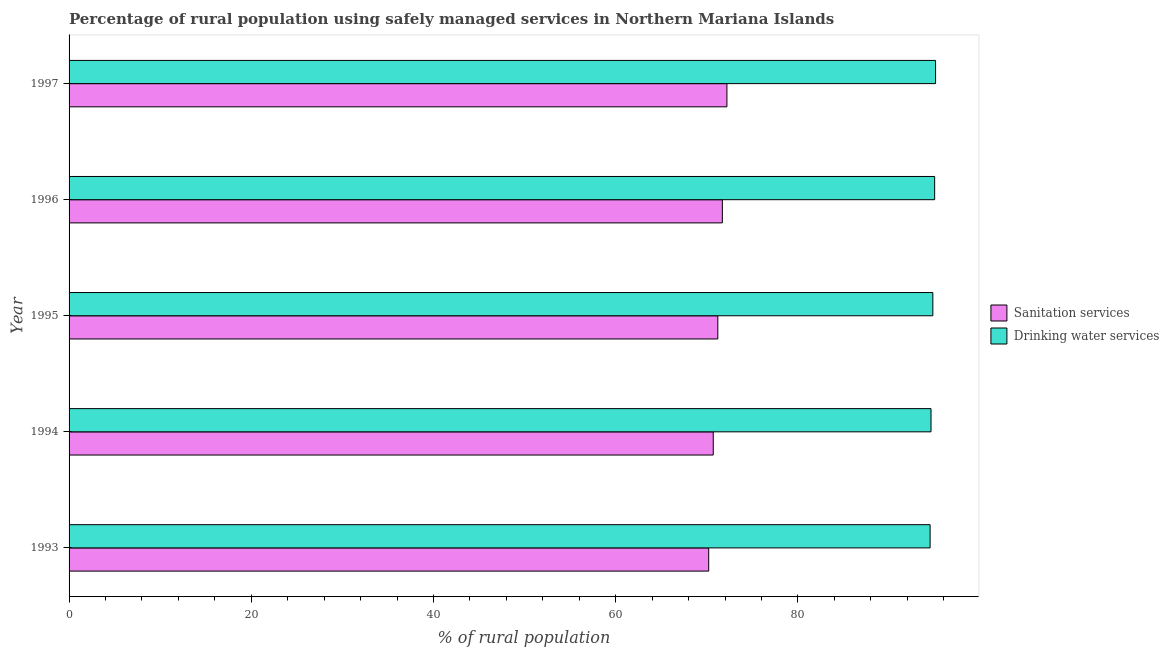How many groups of bars are there?
Ensure brevity in your answer.  5. Are the number of bars on each tick of the Y-axis equal?
Offer a very short reply. Yes. In how many cases, is the number of bars for a given year not equal to the number of legend labels?
Your answer should be compact. 0. What is the percentage of rural population who used drinking water services in 1997?
Your response must be concise. 95.1. Across all years, what is the maximum percentage of rural population who used drinking water services?
Provide a short and direct response. 95.1. Across all years, what is the minimum percentage of rural population who used drinking water services?
Your answer should be compact. 94.5. In which year was the percentage of rural population who used sanitation services maximum?
Provide a succinct answer. 1997. What is the total percentage of rural population who used drinking water services in the graph?
Keep it short and to the point. 474. What is the difference between the percentage of rural population who used drinking water services in 1994 and the percentage of rural population who used sanitation services in 1995?
Provide a succinct answer. 23.4. What is the average percentage of rural population who used drinking water services per year?
Your response must be concise. 94.8. In the year 1995, what is the difference between the percentage of rural population who used sanitation services and percentage of rural population who used drinking water services?
Give a very brief answer. -23.6. In how many years, is the percentage of rural population who used drinking water services greater than 48 %?
Your response must be concise. 5. Is the percentage of rural population who used sanitation services in 1994 less than that in 1996?
Make the answer very short. Yes. What is the difference between the highest and the second highest percentage of rural population who used sanitation services?
Offer a terse response. 0.5. Is the sum of the percentage of rural population who used drinking water services in 1994 and 1997 greater than the maximum percentage of rural population who used sanitation services across all years?
Give a very brief answer. Yes. What does the 2nd bar from the top in 1995 represents?
Make the answer very short. Sanitation services. What does the 1st bar from the bottom in 1995 represents?
Make the answer very short. Sanitation services. How many bars are there?
Offer a terse response. 10. Are all the bars in the graph horizontal?
Make the answer very short. Yes. How many years are there in the graph?
Keep it short and to the point. 5. What is the difference between two consecutive major ticks on the X-axis?
Provide a short and direct response. 20. Are the values on the major ticks of X-axis written in scientific E-notation?
Your answer should be compact. No. Does the graph contain any zero values?
Your answer should be compact. No. Does the graph contain grids?
Offer a very short reply. No. Where does the legend appear in the graph?
Your answer should be very brief. Center right. What is the title of the graph?
Your answer should be very brief. Percentage of rural population using safely managed services in Northern Mariana Islands. Does "Age 65(male)" appear as one of the legend labels in the graph?
Make the answer very short. No. What is the label or title of the X-axis?
Make the answer very short. % of rural population. What is the % of rural population of Sanitation services in 1993?
Keep it short and to the point. 70.2. What is the % of rural population in Drinking water services in 1993?
Ensure brevity in your answer.  94.5. What is the % of rural population in Sanitation services in 1994?
Your answer should be very brief. 70.7. What is the % of rural population in Drinking water services in 1994?
Make the answer very short. 94.6. What is the % of rural population in Sanitation services in 1995?
Keep it short and to the point. 71.2. What is the % of rural population of Drinking water services in 1995?
Provide a succinct answer. 94.8. What is the % of rural population in Sanitation services in 1996?
Your answer should be compact. 71.7. What is the % of rural population in Drinking water services in 1996?
Your answer should be compact. 95. What is the % of rural population in Sanitation services in 1997?
Offer a terse response. 72.2. What is the % of rural population in Drinking water services in 1997?
Give a very brief answer. 95.1. Across all years, what is the maximum % of rural population in Sanitation services?
Make the answer very short. 72.2. Across all years, what is the maximum % of rural population of Drinking water services?
Your answer should be very brief. 95.1. Across all years, what is the minimum % of rural population of Sanitation services?
Your answer should be compact. 70.2. Across all years, what is the minimum % of rural population in Drinking water services?
Keep it short and to the point. 94.5. What is the total % of rural population in Sanitation services in the graph?
Offer a very short reply. 356. What is the total % of rural population of Drinking water services in the graph?
Your answer should be very brief. 474. What is the difference between the % of rural population in Sanitation services in 1993 and that in 1994?
Ensure brevity in your answer.  -0.5. What is the difference between the % of rural population in Drinking water services in 1993 and that in 1994?
Offer a very short reply. -0.1. What is the difference between the % of rural population in Sanitation services in 1993 and that in 1996?
Provide a short and direct response. -1.5. What is the difference between the % of rural population in Drinking water services in 1993 and that in 1996?
Keep it short and to the point. -0.5. What is the difference between the % of rural population of Sanitation services in 1994 and that in 1997?
Offer a very short reply. -1.5. What is the difference between the % of rural population of Sanitation services in 1995 and that in 1996?
Your answer should be very brief. -0.5. What is the difference between the % of rural population in Drinking water services in 1995 and that in 1996?
Your answer should be compact. -0.2. What is the difference between the % of rural population in Sanitation services in 1995 and that in 1997?
Offer a very short reply. -1. What is the difference between the % of rural population of Drinking water services in 1995 and that in 1997?
Offer a very short reply. -0.3. What is the difference between the % of rural population in Sanitation services in 1996 and that in 1997?
Your answer should be very brief. -0.5. What is the difference between the % of rural population of Drinking water services in 1996 and that in 1997?
Make the answer very short. -0.1. What is the difference between the % of rural population of Sanitation services in 1993 and the % of rural population of Drinking water services in 1994?
Your answer should be very brief. -24.4. What is the difference between the % of rural population of Sanitation services in 1993 and the % of rural population of Drinking water services in 1995?
Offer a terse response. -24.6. What is the difference between the % of rural population in Sanitation services in 1993 and the % of rural population in Drinking water services in 1996?
Give a very brief answer. -24.8. What is the difference between the % of rural population in Sanitation services in 1993 and the % of rural population in Drinking water services in 1997?
Offer a terse response. -24.9. What is the difference between the % of rural population of Sanitation services in 1994 and the % of rural population of Drinking water services in 1995?
Keep it short and to the point. -24.1. What is the difference between the % of rural population in Sanitation services in 1994 and the % of rural population in Drinking water services in 1996?
Keep it short and to the point. -24.3. What is the difference between the % of rural population in Sanitation services in 1994 and the % of rural population in Drinking water services in 1997?
Offer a terse response. -24.4. What is the difference between the % of rural population in Sanitation services in 1995 and the % of rural population in Drinking water services in 1996?
Your response must be concise. -23.8. What is the difference between the % of rural population in Sanitation services in 1995 and the % of rural population in Drinking water services in 1997?
Give a very brief answer. -23.9. What is the difference between the % of rural population in Sanitation services in 1996 and the % of rural population in Drinking water services in 1997?
Offer a terse response. -23.4. What is the average % of rural population of Sanitation services per year?
Make the answer very short. 71.2. What is the average % of rural population of Drinking water services per year?
Provide a short and direct response. 94.8. In the year 1993, what is the difference between the % of rural population of Sanitation services and % of rural population of Drinking water services?
Provide a short and direct response. -24.3. In the year 1994, what is the difference between the % of rural population in Sanitation services and % of rural population in Drinking water services?
Keep it short and to the point. -23.9. In the year 1995, what is the difference between the % of rural population in Sanitation services and % of rural population in Drinking water services?
Provide a short and direct response. -23.6. In the year 1996, what is the difference between the % of rural population of Sanitation services and % of rural population of Drinking water services?
Give a very brief answer. -23.3. In the year 1997, what is the difference between the % of rural population in Sanitation services and % of rural population in Drinking water services?
Ensure brevity in your answer.  -22.9. What is the ratio of the % of rural population of Sanitation services in 1993 to that in 1994?
Make the answer very short. 0.99. What is the ratio of the % of rural population of Drinking water services in 1993 to that in 1995?
Give a very brief answer. 1. What is the ratio of the % of rural population in Sanitation services in 1993 to that in 1996?
Make the answer very short. 0.98. What is the ratio of the % of rural population of Drinking water services in 1993 to that in 1996?
Offer a terse response. 0.99. What is the ratio of the % of rural population of Sanitation services in 1993 to that in 1997?
Your answer should be very brief. 0.97. What is the ratio of the % of rural population of Sanitation services in 1994 to that in 1996?
Offer a terse response. 0.99. What is the ratio of the % of rural population in Sanitation services in 1994 to that in 1997?
Keep it short and to the point. 0.98. What is the ratio of the % of rural population of Drinking water services in 1994 to that in 1997?
Make the answer very short. 0.99. What is the ratio of the % of rural population in Drinking water services in 1995 to that in 1996?
Provide a succinct answer. 1. What is the ratio of the % of rural population of Sanitation services in 1995 to that in 1997?
Offer a very short reply. 0.99. What is the difference between the highest and the second highest % of rural population in Drinking water services?
Your answer should be compact. 0.1. 